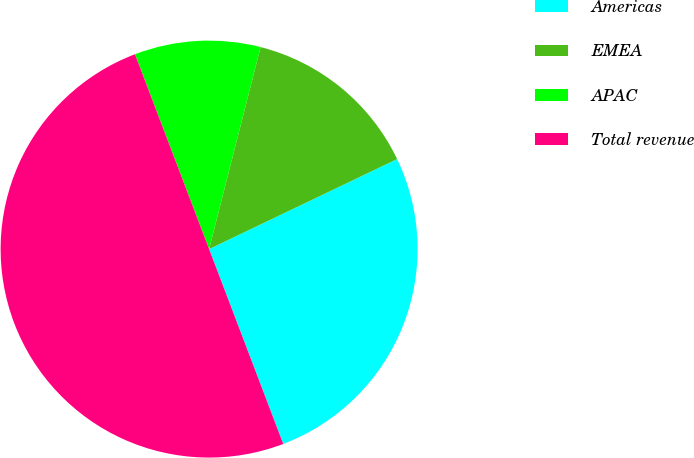Convert chart. <chart><loc_0><loc_0><loc_500><loc_500><pie_chart><fcel>Americas<fcel>EMEA<fcel>APAC<fcel>Total revenue<nl><fcel>26.32%<fcel>13.92%<fcel>9.76%<fcel>50.0%<nl></chart> 